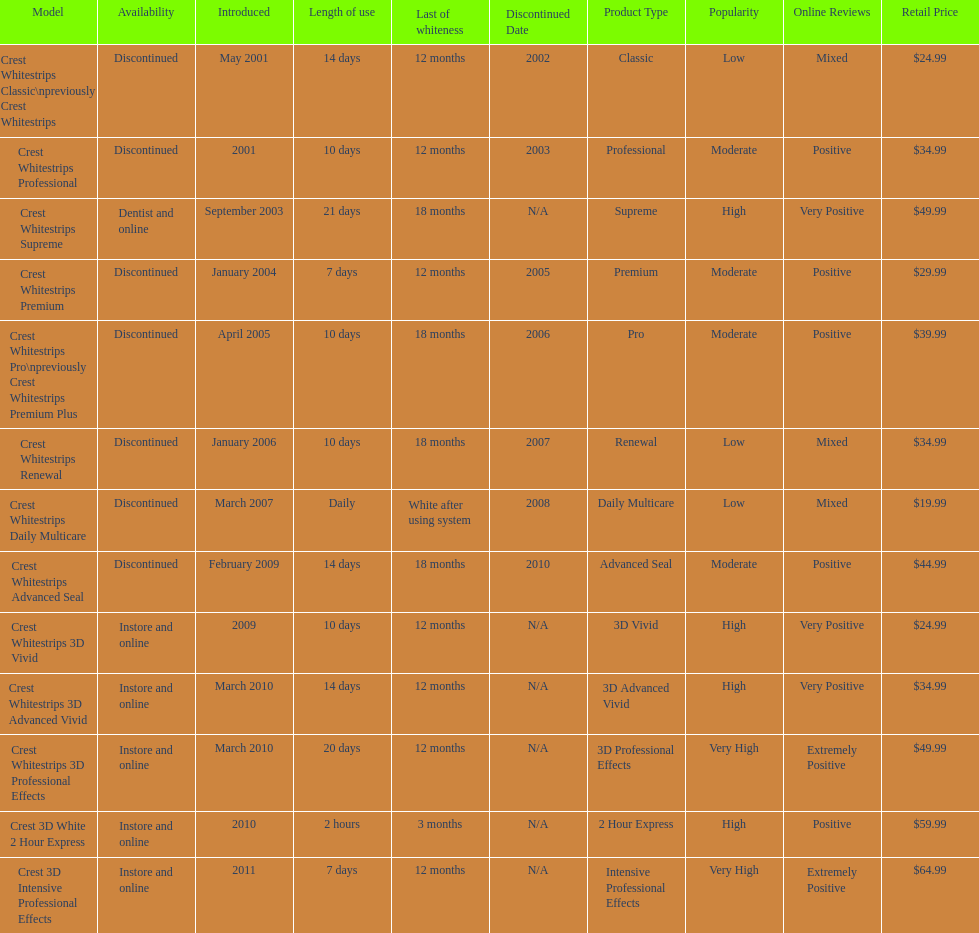Does the crest white strips classic last at least one year? Yes. 